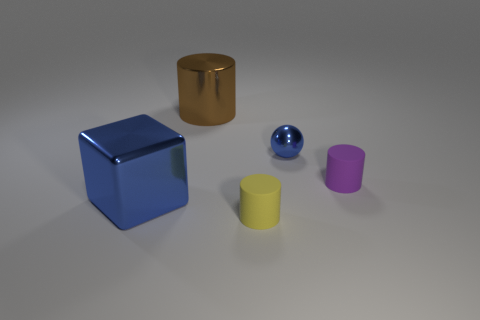There is a brown object that is the same material as the tiny ball; what size is it? The brown object, which appears to be a cylinder, is substantially larger than the small blue ball. While the exact dimensions are not provided, visually comparing the two suggests that the cylinder's height and diameter could be roughly three to four times the diameter of the small ball. 